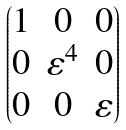Convert formula to latex. <formula><loc_0><loc_0><loc_500><loc_500>\begin{pmatrix} 1 & 0 & 0 \\ 0 & \varepsilon ^ { 4 } & 0 \\ 0 & 0 & \varepsilon \end{pmatrix}</formula> 